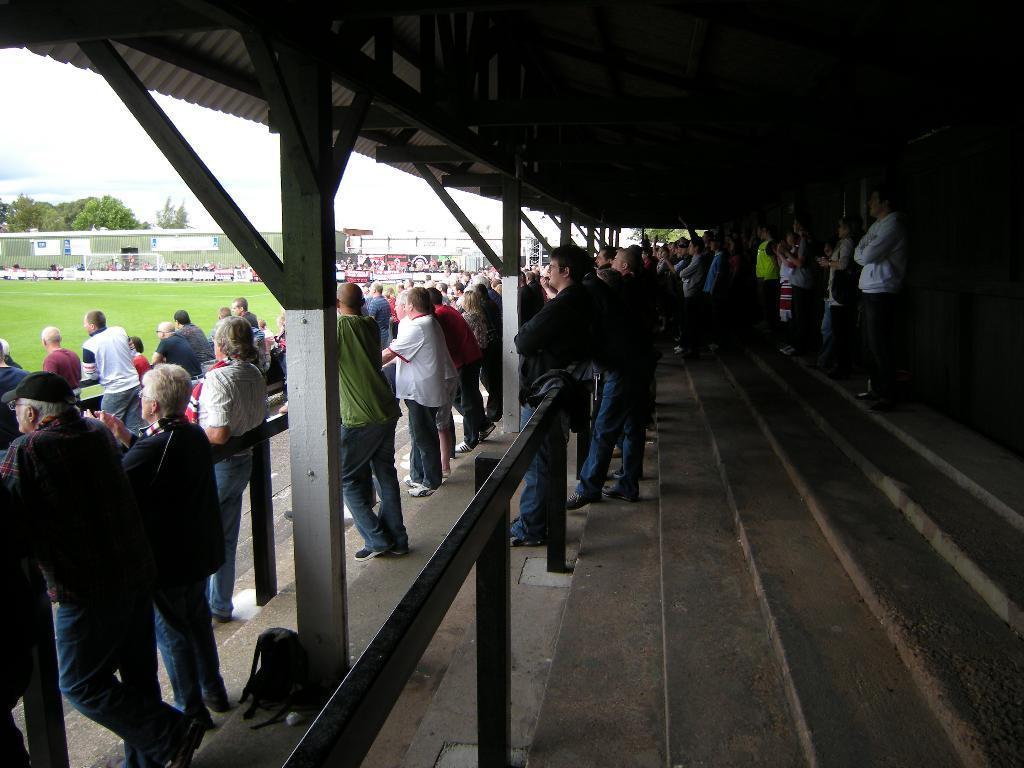Could you give a brief overview of what you see in this image? In this picture, we see many people are standing. In front of them, we see the iron railing or iron roads. In the middle of the picture, we see the iron rods and a bag beside that. At the top, we see the roof. On the right side, we see the staircase and the people are standing on the staircase. On the left side, we see the grass. We see people are standing in the background. Behind them, we see the building and behind that, we see the trees and the sky. 